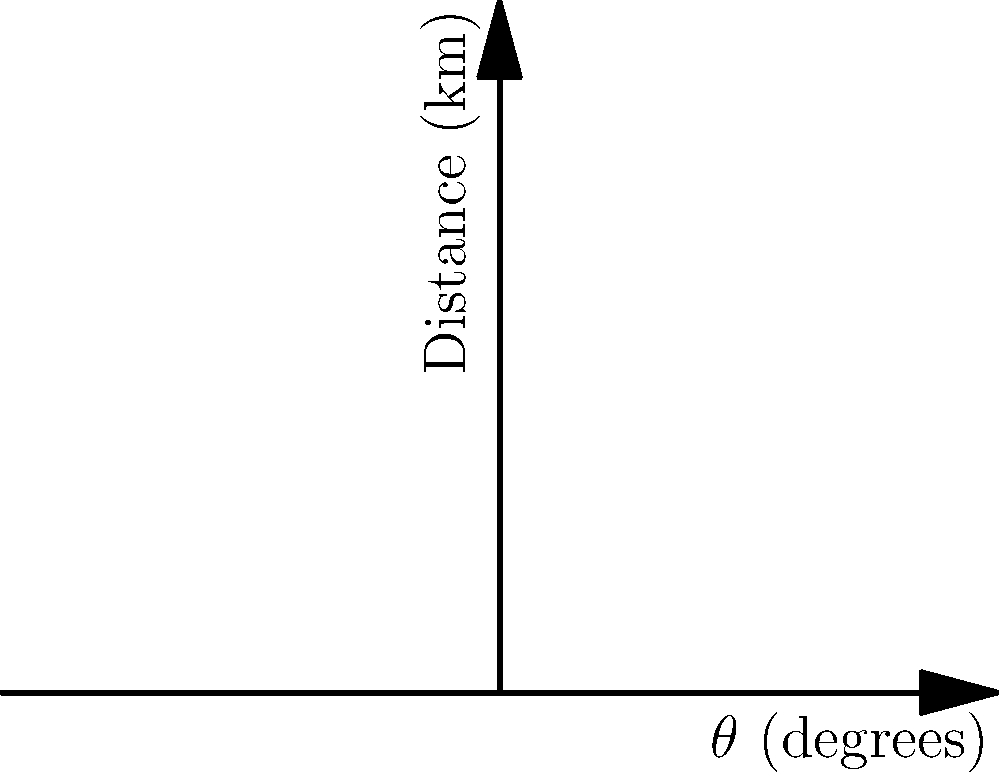The polar coordinate graph shows the migration patterns of three threatened animal species: Monarch Butterfly, Arctic Tern, and Leatherback Turtle. Which species travels the greatest distance at the 90-degree mark on their migration route? To determine which species travels the greatest distance at the 90-degree mark, we need to follow these steps:

1. Identify the 90-degree mark on the $\theta$ axis.
2. For each species, find the point where their migration path intersects the 90-degree line.
3. Compare the distances (r-values) for each species at this point.

Let's examine each species:

1. Monarch Butterfly (red line):
   At 90 degrees, the distance is approximately 150 km.

2. Arctic Tern (blue line):
   At 90 degrees, the distance is approximately 200 km.

3. Leatherback Turtle (green line):
   At 90 degrees, the distance is approximately 150 km.

Comparing these values, we can see that the Arctic Tern has the greatest distance at the 90-degree mark, reaching about 200 km.

This analysis helps us understand the migration patterns of these threatened species, which is crucial for conservation efforts and protecting their habitats along their migration routes.
Answer: Arctic Tern 